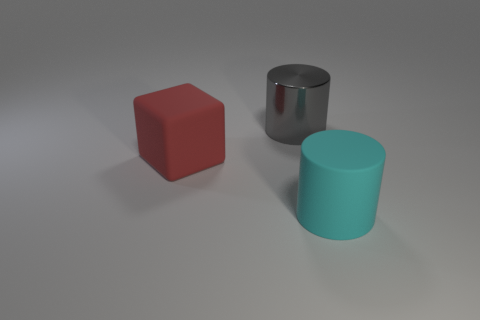Is there any other thing that has the same material as the large gray thing?
Provide a succinct answer. No. How many other objects are the same color as the shiny thing?
Provide a succinct answer. 0. Do the large cylinder in front of the big red rubber cube and the thing left of the big gray thing have the same material?
Your response must be concise. Yes. There is another large thing that is the same shape as the large cyan rubber object; what is it made of?
Give a very brief answer. Metal. What is the shape of the object that is on the right side of the big gray metal object?
Your response must be concise. Cylinder. How many other objects have the same shape as the metal object?
Offer a very short reply. 1. Are there an equal number of shiny cylinders in front of the big metallic cylinder and big cylinders that are behind the cyan rubber cylinder?
Give a very brief answer. No. Are there any big gray objects that have the same material as the big cyan cylinder?
Ensure brevity in your answer.  No. Are the big cyan object and the block made of the same material?
Ensure brevity in your answer.  Yes. What number of cyan objects are large cubes or large objects?
Your answer should be compact. 1. 